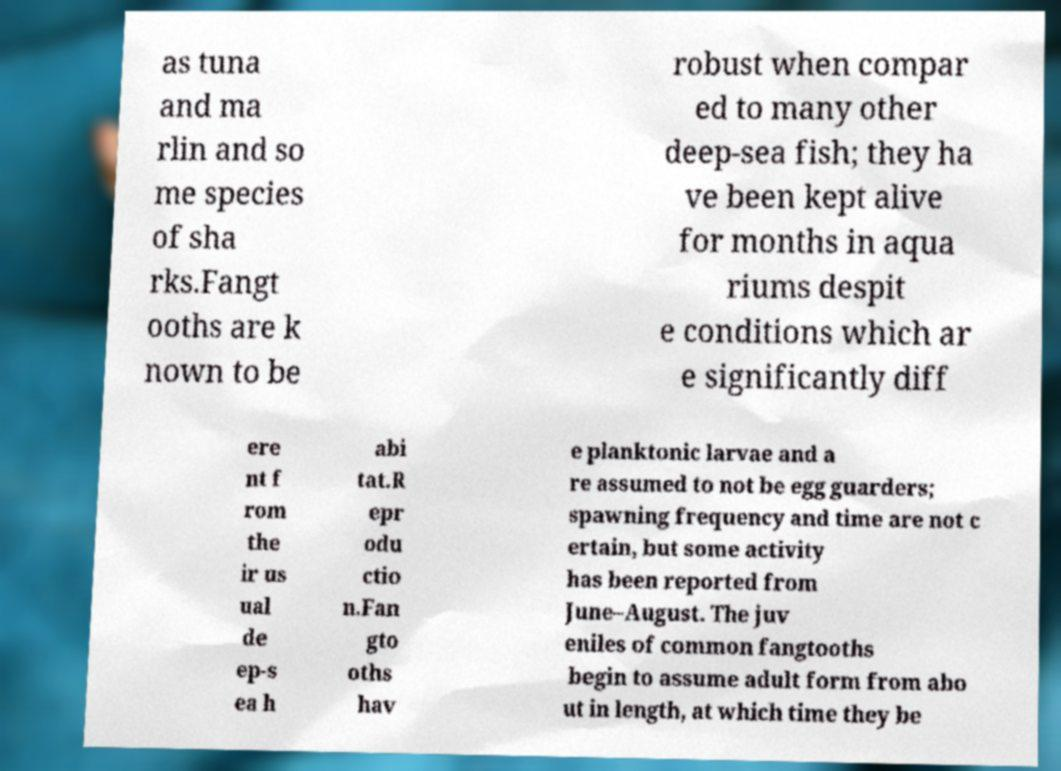I need the written content from this picture converted into text. Can you do that? as tuna and ma rlin and so me species of sha rks.Fangt ooths are k nown to be robust when compar ed to many other deep-sea fish; they ha ve been kept alive for months in aqua riums despit e conditions which ar e significantly diff ere nt f rom the ir us ual de ep-s ea h abi tat.R epr odu ctio n.Fan gto oths hav e planktonic larvae and a re assumed to not be egg guarders; spawning frequency and time are not c ertain, but some activity has been reported from June–August. The juv eniles of common fangtooths begin to assume adult form from abo ut in length, at which time they be 